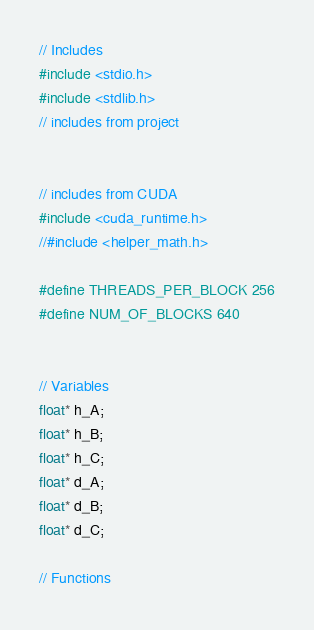Convert code to text. <code><loc_0><loc_0><loc_500><loc_500><_Cuda_>// Includes
#include <stdio.h>
#include <stdlib.h>
// includes from project


// includes from CUDA
#include <cuda_runtime.h>
//#include <helper_math.h>

#define THREADS_PER_BLOCK 256
#define NUM_OF_BLOCKS 640


// Variables
float* h_A;
float* h_B;
float* h_C;
float* d_A;
float* d_B;
float* d_C;

// Functions</code> 